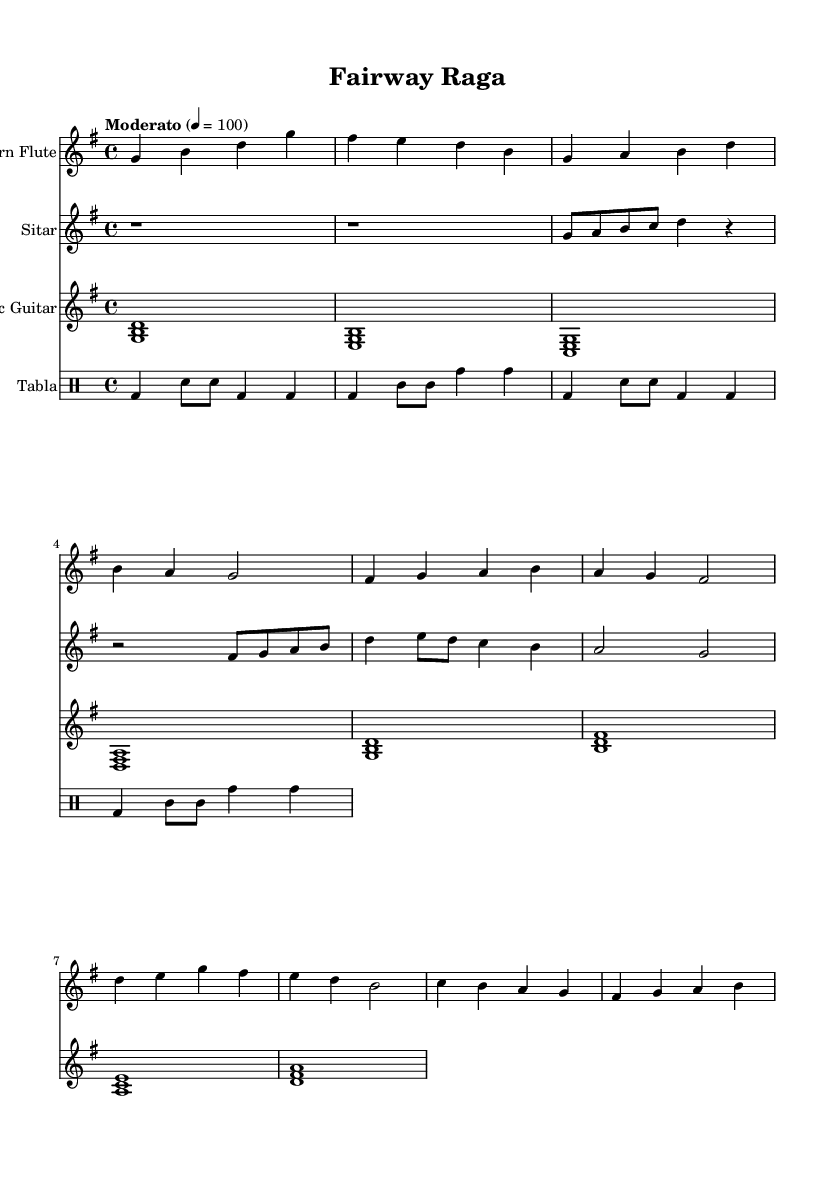What is the key signature of this music? The key signature is G major, indicated by one sharp (F#) in the music notation.
Answer: G major What is the time signature of this music? The time signature is 4/4, which is a common time signature that denotes four beats per measure.
Answer: 4/4 What is the tempo marking of this piece? The tempo marking is "Moderato," which suggests a moderate pace for the music.
Answer: Moderato How many measures are in the flute part? Counting the measures in the flute part, there are six measures present in the excerpt provided.
Answer: Six Which instruments are used in this score? The instruments indicated in the score are the flute, sitar, acoustic guitar, and tabla, which combine Western and Indian sounds.
Answer: Flute, sitar, acoustic guitar, tabla What is the primary style of this composition? The style can be identified as Romantic, focusing on melodic fusion that combines elements from both Western and Indian musical traditions.
Answer: Romantic What rhythm does the tabla primarily utilize? The tabla primarily utilizes a combination of basic beats (bd) and different strokes (sn, tomm) that create a rhythmic pattern throughout the piece.
Answer: Rhythmic pattern 